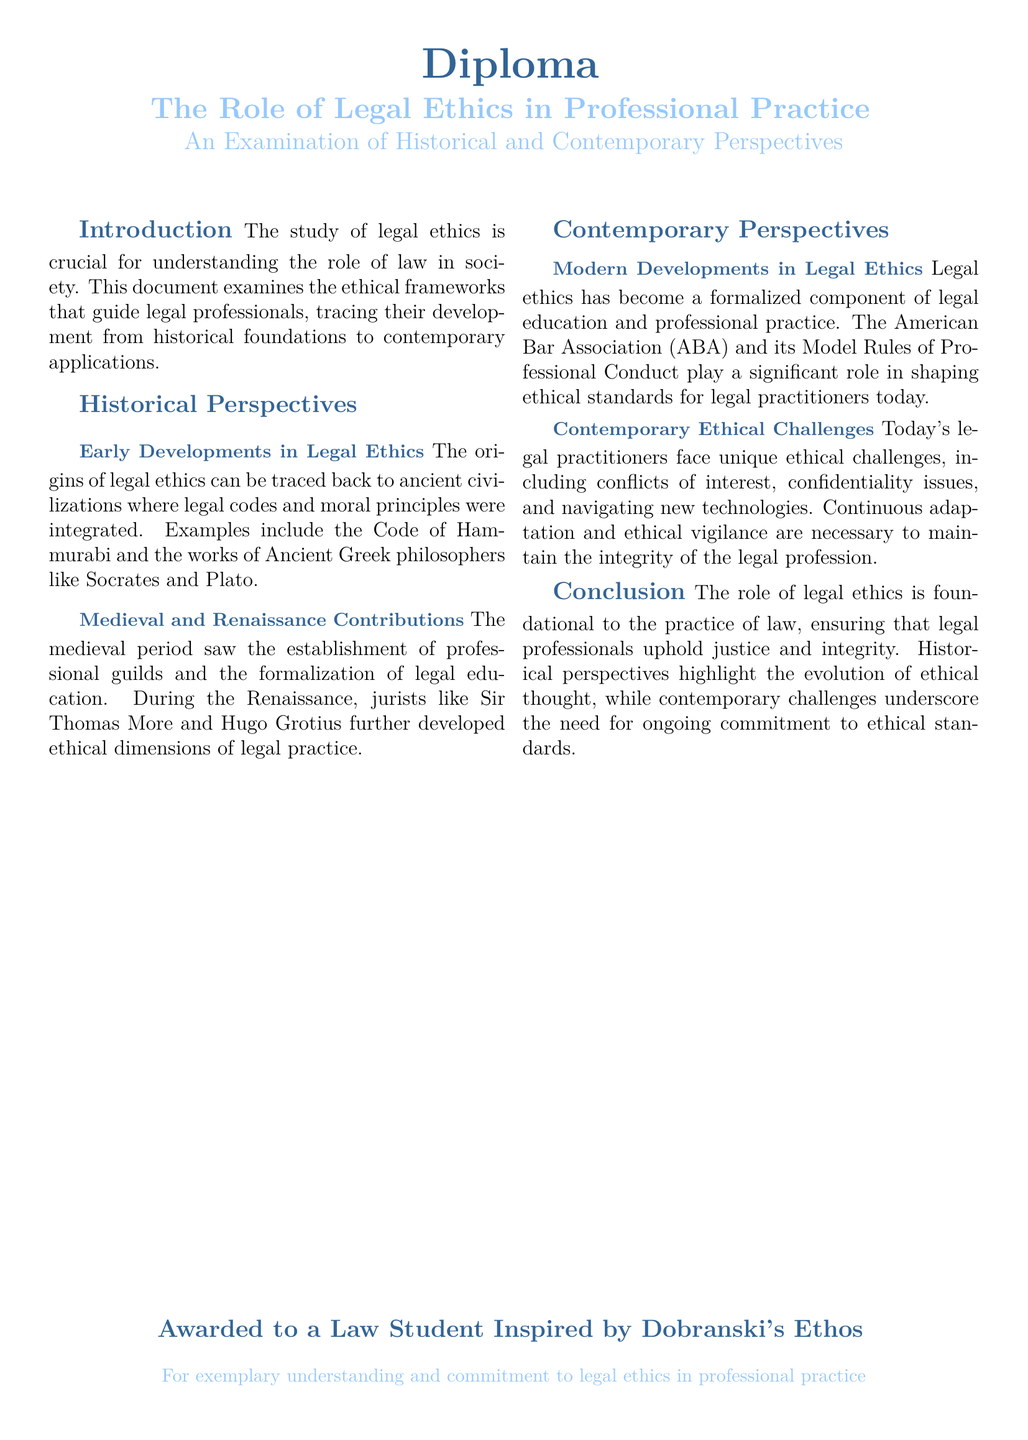What is the title of the diploma? The title of the diploma is stated prominently at the top of the document.
Answer: The Role of Legal Ethics in Professional Practice Who developed the Model Rules of Professional Conduct? The document mentions that the American Bar Association (ABA) plays a significant role in shaping ethical standards.
Answer: American Bar Association What civilization's legal code is mentioned in the historical perspectives? The document refers to ancient civilizations and provides an example of a specific legal code.
Answer: Code of Hammurabi Which philosopher's works are highlighted in early developments of legal ethics? The document references contributions from various ancient philosophers.
Answer: Socrates What contemporary issue is discussed in relation to ethical challenges? The document points out various unique challenges faced by legal practitioners today.
Answer: Confidentiality issues 